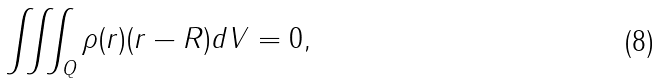<formula> <loc_0><loc_0><loc_500><loc_500>\iiint _ { Q } \rho ( r ) ( r - R ) d V = 0 ,</formula> 